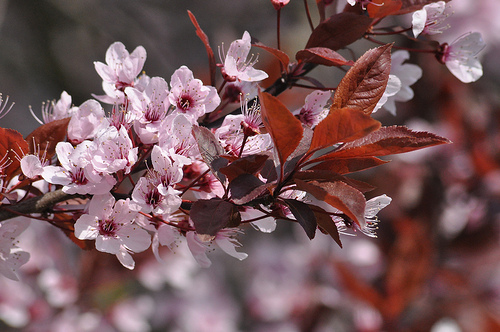<image>
Is the branch in front of the petal? No. The branch is not in front of the petal. The spatial positioning shows a different relationship between these objects. 